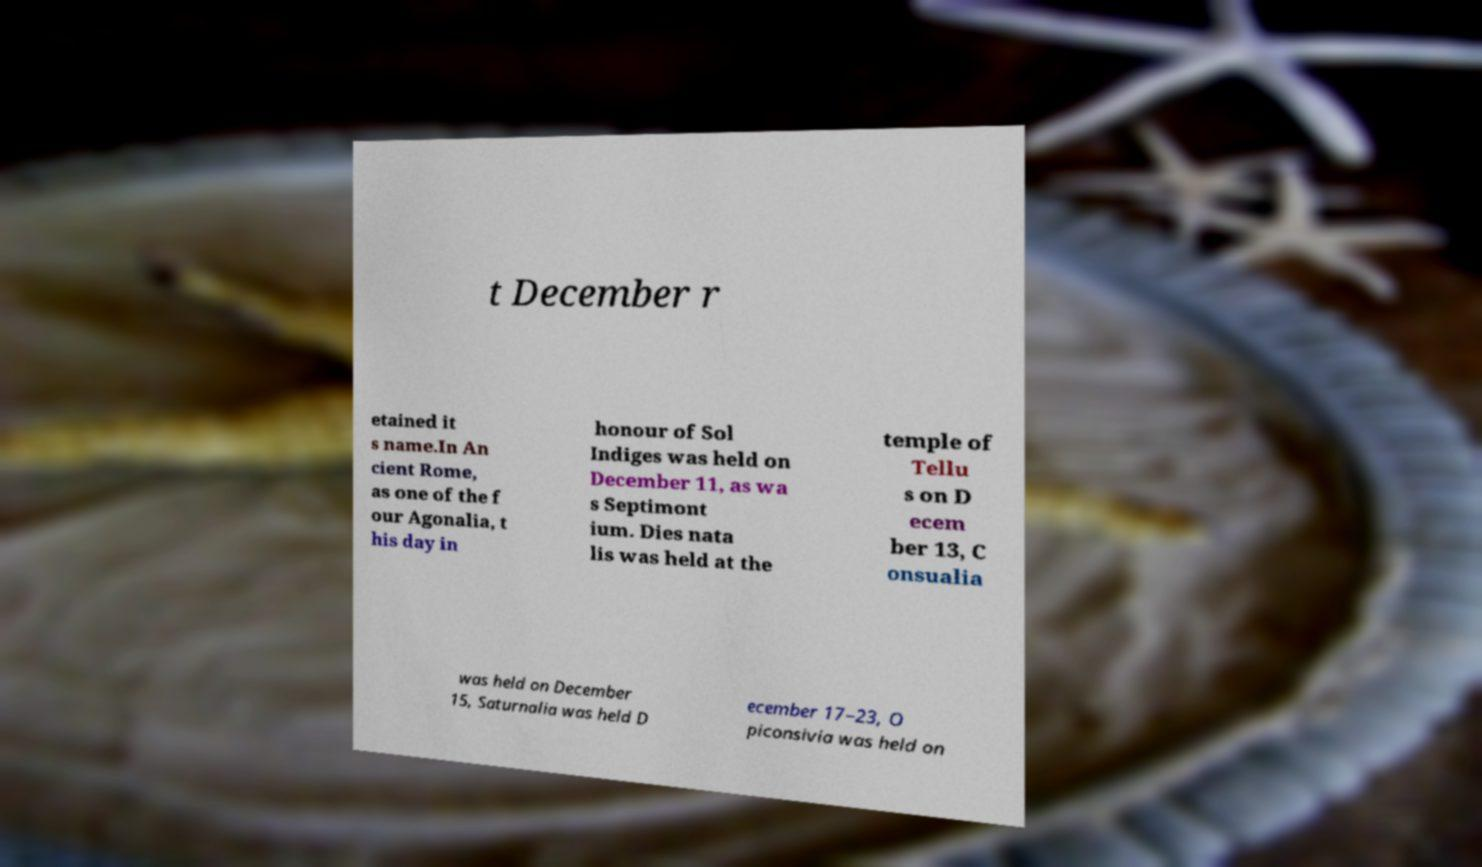Could you extract and type out the text from this image? t December r etained it s name.In An cient Rome, as one of the f our Agonalia, t his day in honour of Sol Indiges was held on December 11, as wa s Septimont ium. Dies nata lis was held at the temple of Tellu s on D ecem ber 13, C onsualia was held on December 15, Saturnalia was held D ecember 17–23, O piconsivia was held on 